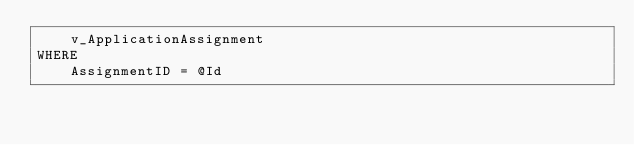Convert code to text. <code><loc_0><loc_0><loc_500><loc_500><_SQL_>    v_ApplicationAssignment
WHERE
    AssignmentID = @Id</code> 